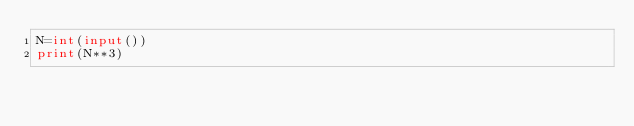<code> <loc_0><loc_0><loc_500><loc_500><_Python_>N=int(input())
print(N**3)</code> 